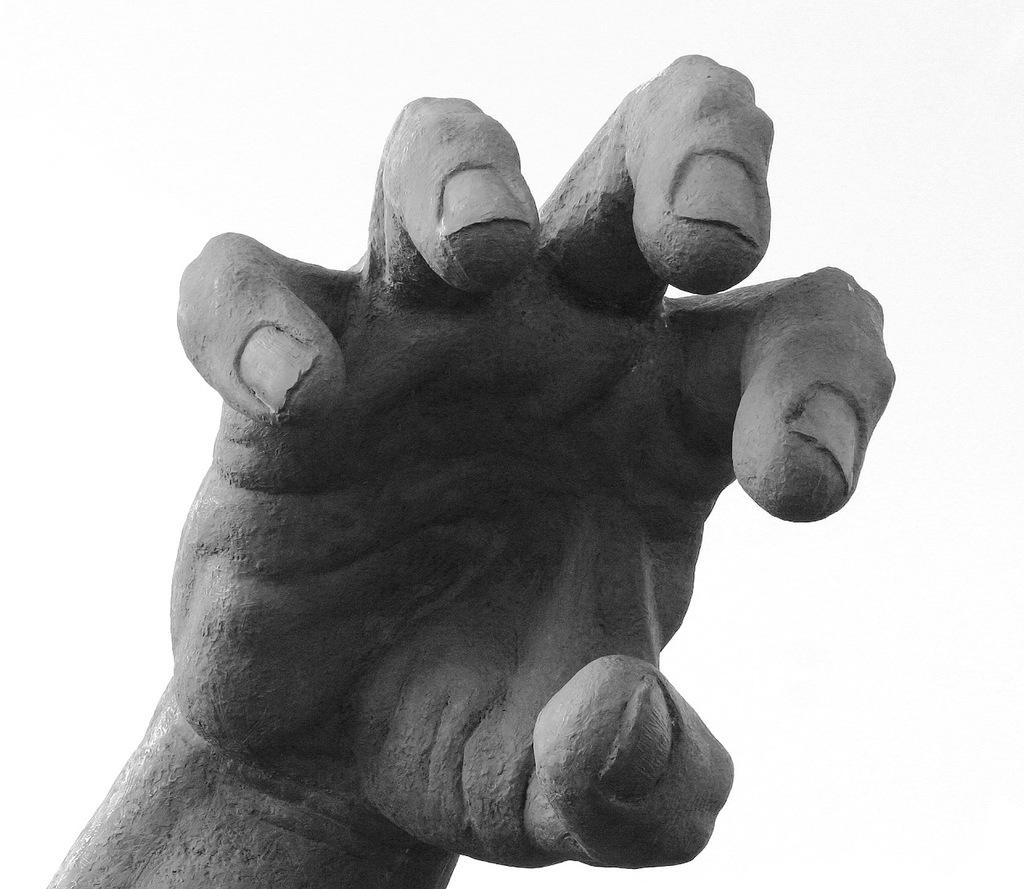What is the main subject of the image? The main subject of the image is a statue of a person's hand. What color is the background of the image? The background of the image is white in color. What type of hen can be seen in the image? There is no hen present in the image; it features a statue of a person's hand. What type of drug is being used by the person in the image? There is no person or drug present in the image; it features a statue of a person's hand. 